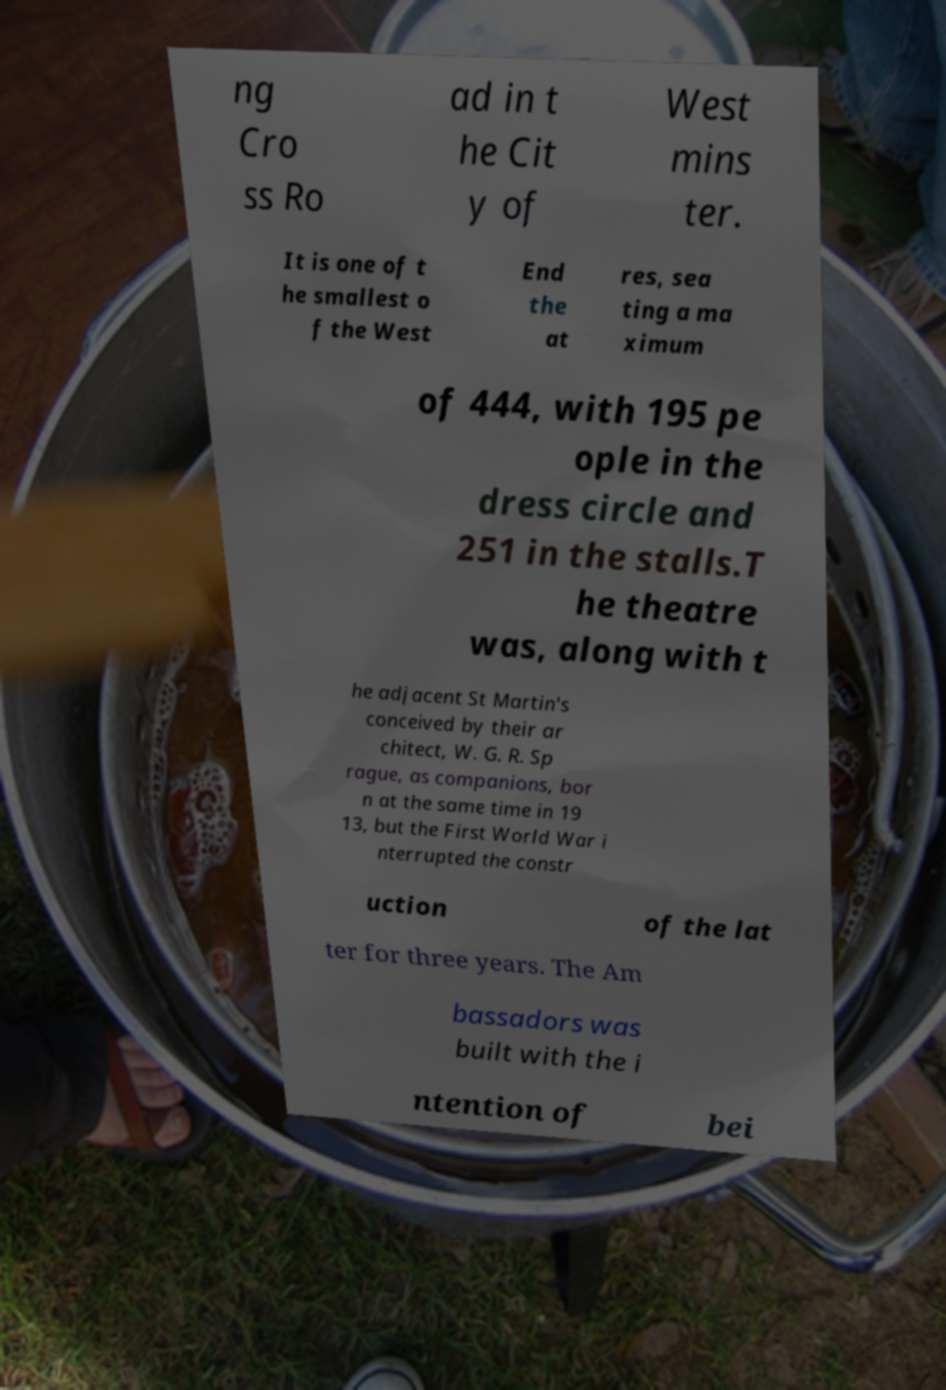Please identify and transcribe the text found in this image. ng Cro ss Ro ad in t he Cit y of West mins ter. It is one of t he smallest o f the West End the at res, sea ting a ma ximum of 444, with 195 pe ople in the dress circle and 251 in the stalls.T he theatre was, along with t he adjacent St Martin's conceived by their ar chitect, W. G. R. Sp rague, as companions, bor n at the same time in 19 13, but the First World War i nterrupted the constr uction of the lat ter for three years. The Am bassadors was built with the i ntention of bei 